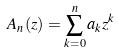Convert formula to latex. <formula><loc_0><loc_0><loc_500><loc_500>A _ { n } ( z ) = \sum _ { k = 0 } ^ { n } a _ { k } z ^ { k }</formula> 